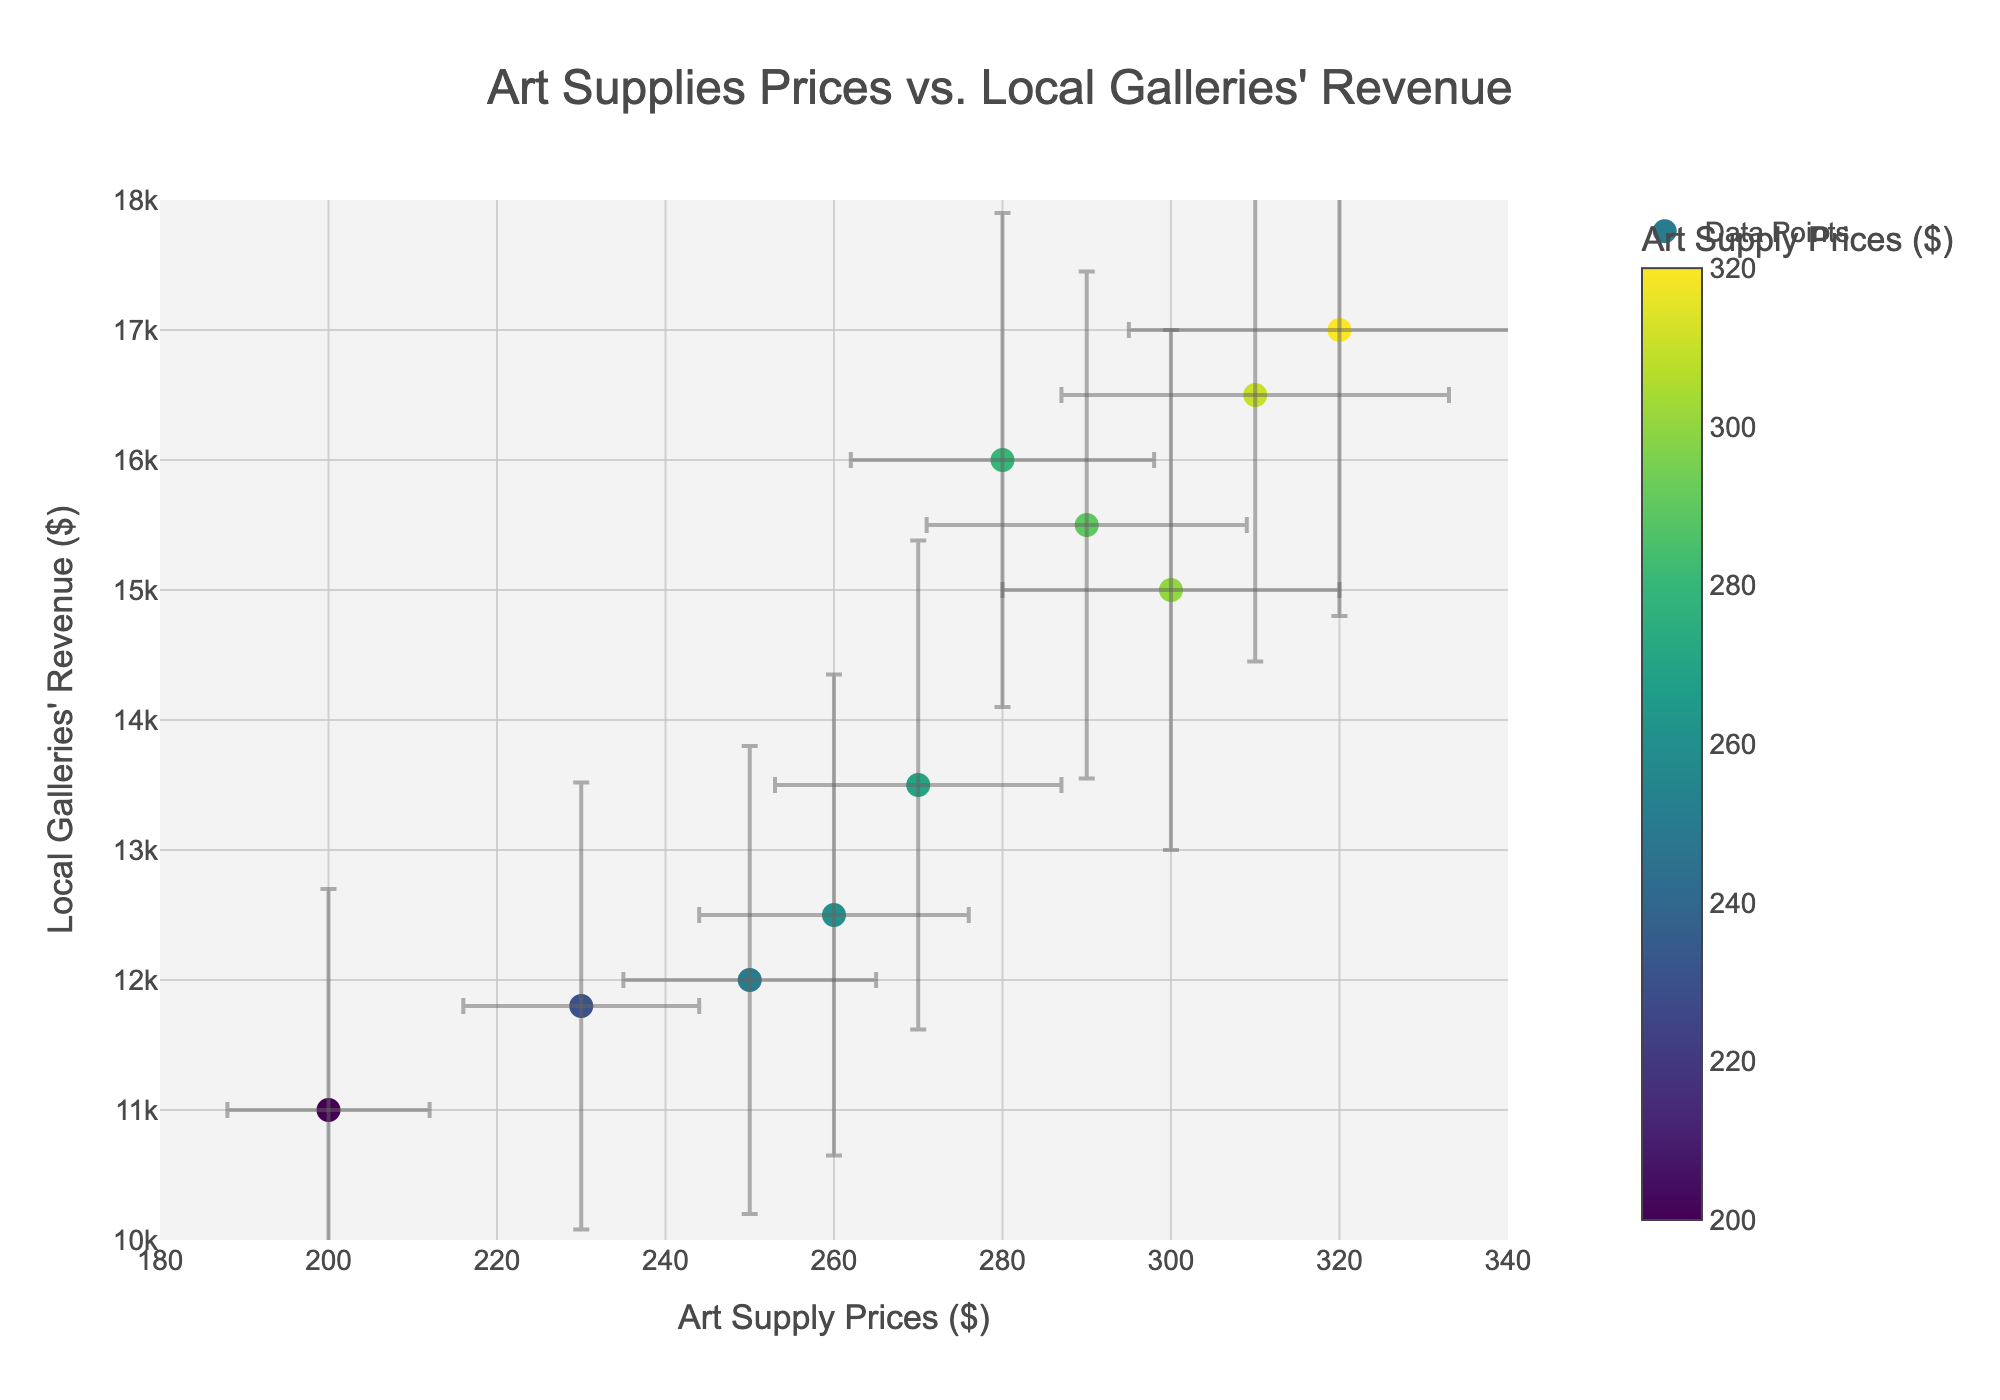What's the title of the figure? The title is positioned at the top center of the figure and provides an overview of what the plot is about. The title can be seen as "Art Supplies Prices vs. Local Galleries' Revenue."
Answer: Art Supplies Prices vs. Local Galleries' Revenue What are the axes' titles? The axes' titles are the descriptive labels given to the x and y axes. The x-axis is labeled "Art Supply Prices ($)", and the y-axis is labeled "Local Galleries' Revenue ($)."
Answer: Art Supply Prices ($) and Local Galleries' Revenue ($) How many neighborhoods are represented in the plot? Each neighborhood is represented as a unique data point on the scatter plot. By counting the data points and checking the hover information (neighborhood names), we can see there are 10 neighborhoods.
Answer: 10 Which neighborhood has the highest art supply prices? We need to locate the data point on the x-axis corresponding to the highest value. The highest art supply price value is $320, which corresponds to the neighborhood SoHo.
Answer: SoHo Which neighborhood has the lowest local galleries' revenue? We need to locate the data point on the y-axis corresponding to the lowest value. The lowest local galleries' revenue value is $11,000, which corresponds to the neighborhood Harlem.
Answer: Harlem What is the average of art supply prices across all neighborhoods? To find the average art supply prices, sum up each value for art supply prices and divide by the number of data points (250 + 300 + 280 + 200 + 320 + 290 + 310 + 260 + 230 + 270) / 10 = 271
Answer: 271 Compare the art supply prices of Williamsburg and Harlem. By comparing the x-values of Williamsburg and Harlem, we find Williamsburg has art supply prices of $300 while Harlem has $200. Williamsburg < Harlem.
Answer: Williamsburg > Harlem Is there a general trend between art supply prices and galleries' revenue? Observing the figure illustrates that higher art supply prices tend to cluster with higher gallery revenues, indicating a possible positive relationship between these variables.
Answer: Positive relationship What are the error margins for art supply prices and galleries' revenue in Greenwich Village? Greenwich Village errors are shown as bars. The error in art supply prices is $18 and for galleries' revenue is $1,900.
Answer: $18 and $1,900 Which neighborhood has the widest error bar for art supply prices? Reviewing the horizontal error bars, the neighborhood with the widest error bar for prices is SoHo with an error range of $25.
Answer: SoHo 